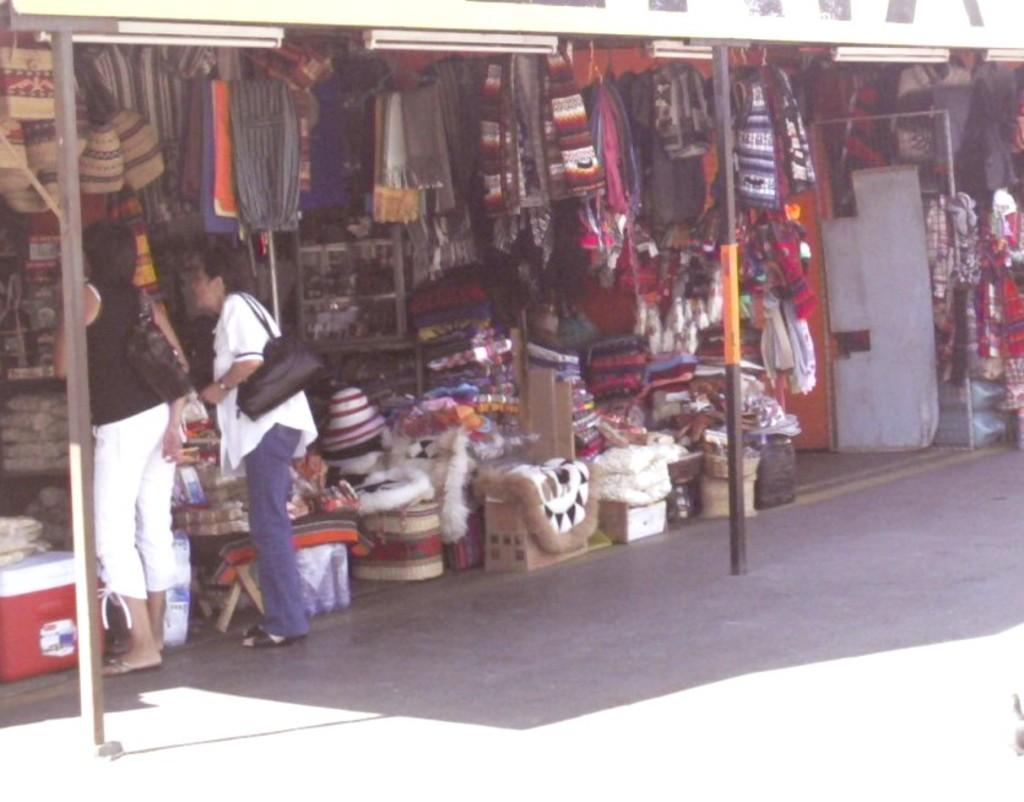What type of structures are present in the image? There are stalls in the image. Can you describe the people present in the image? There are two ladies on the left side of the image. What type of yarn is being sold at the stalls in the image? There is no yarn present in the image; it only shows stalls and two ladies. What type of fuel is being used by the donkey in the image? There is no donkey present in the image, so it is not possible to determine what type of fuel it might be using. 